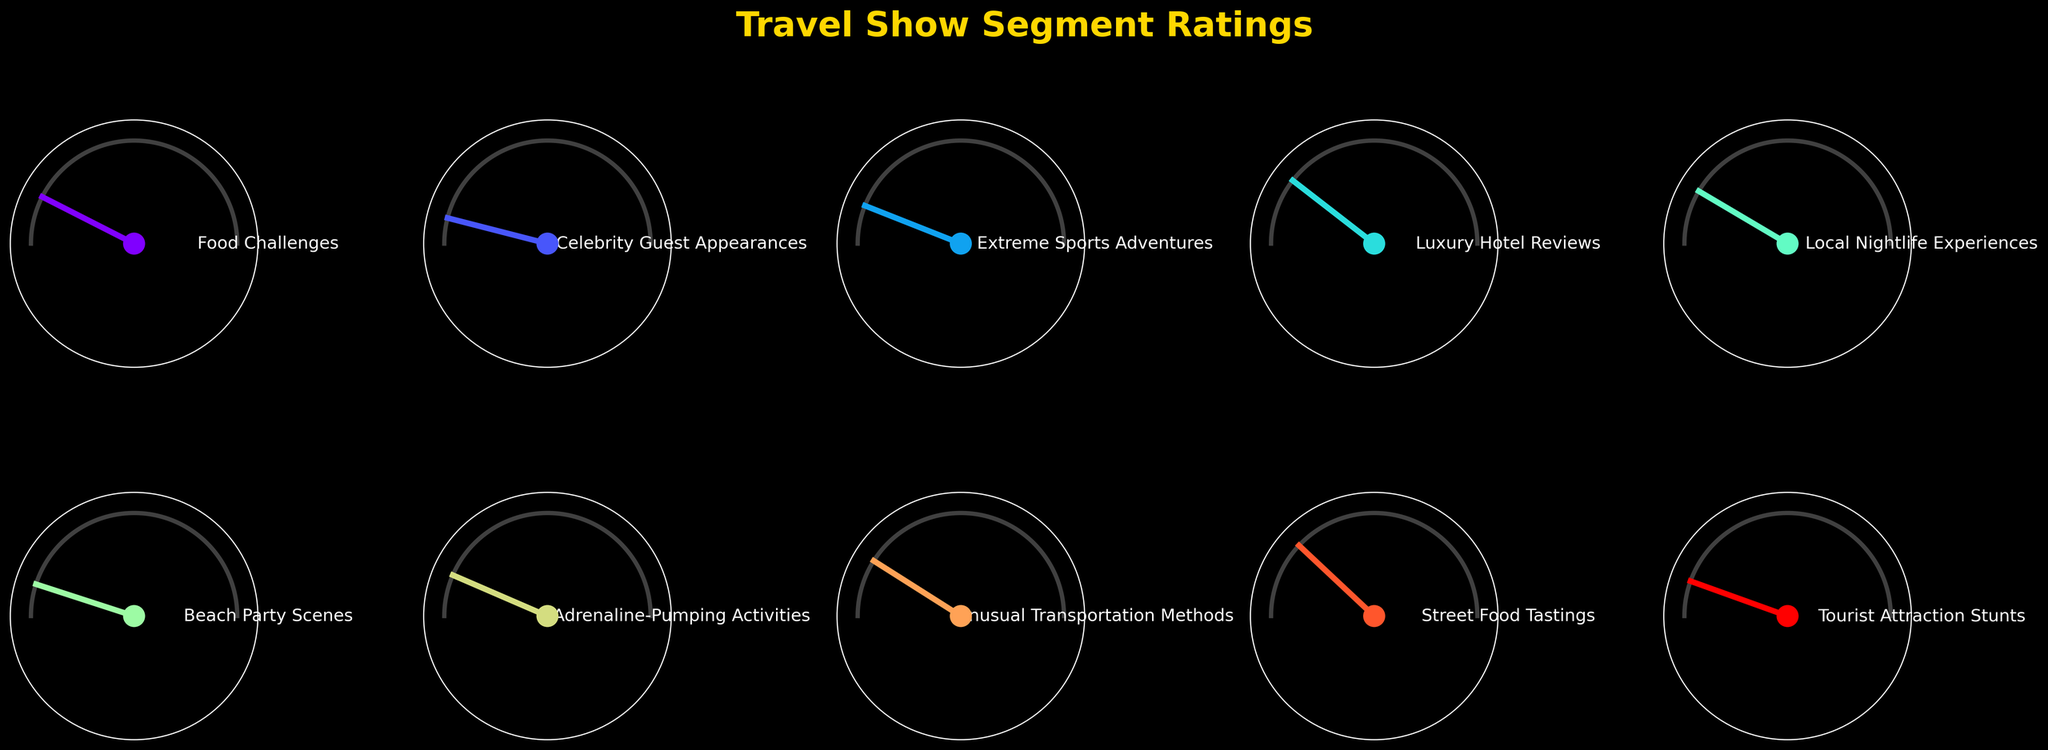What is the title of the figure? The title is typically located at the top of the figure. In this case, it reads "Travel Show Segment Ratings".
Answer: Travel Show Segment Ratings How many segments are displayed in the figure? By counting each distinct segment labeled on the gauge charts, we can see that there are a total of 10 segments displayed.
Answer: 10 Which segment has the highest viewer satisfaction rating, and what is its rating? By looking at each gauge chart, we see that "Celebrity Guest Appearances" has the highest rating at 92%.
Answer: Celebrity Guest Appearances, 92% Which segment has the lowest rating? By inspecting the ratings shown in each gauge, "Street Food Tastings" has the lowest rating at 76%.
Answer: Street Food Tastings, 76% What is the range of ratings in the displayed segments? The range is calculated by subtracting the lowest rating from the highest rating. The highest rating is 92% and the lowest is 76%, so the range is 92 - 76 = 16%.
Answer: 16% What is the average viewer satisfaction rating across all segments? To find the average, add all the segment ratings: 85 + 92 + 88 + 79 + 83 + 90 + 87 + 82 + 76 + 89 = 851. Then divide by the number of segments, 10. So, 851/10 = 85.1%.
Answer: 85.1% How many segments have a rating of 85% or higher? By checking each segment's rating, we identify "Food Challenges" (85), "Celebrity Guest Appearances" (92), "Extreme Sports Adventures" (88), "Beach Party Scenes" (90), "Adrenaline-Pumping Activities" (87), and "Tourist Attraction Stunts" (89) meeting this criterion. There are 6 segments.
Answer: 6 Which segments have ratings above the average rating? The average rating is 85.1%. Segments with ratings above this are "Celebrity Guest Appearances" (92), "Extreme Sports Adventures" (88), "Beach Party Scenes" (90), "Adrenaline-Pumping Activities" (87), and "Tourist Attraction Stunts" (89).
Answer: Celebrity Guest Appearances, Extreme Sports Adventures, Beach Party Scenes, Adrenaline-Pumping Activities, Tourist Attraction Stunts Which segment has the closest rating to the average rating? The average rating is 85.1%. The segment "Food Challenges" has a rating of 85, which is the closest to the average.
Answer: Food Challenges 